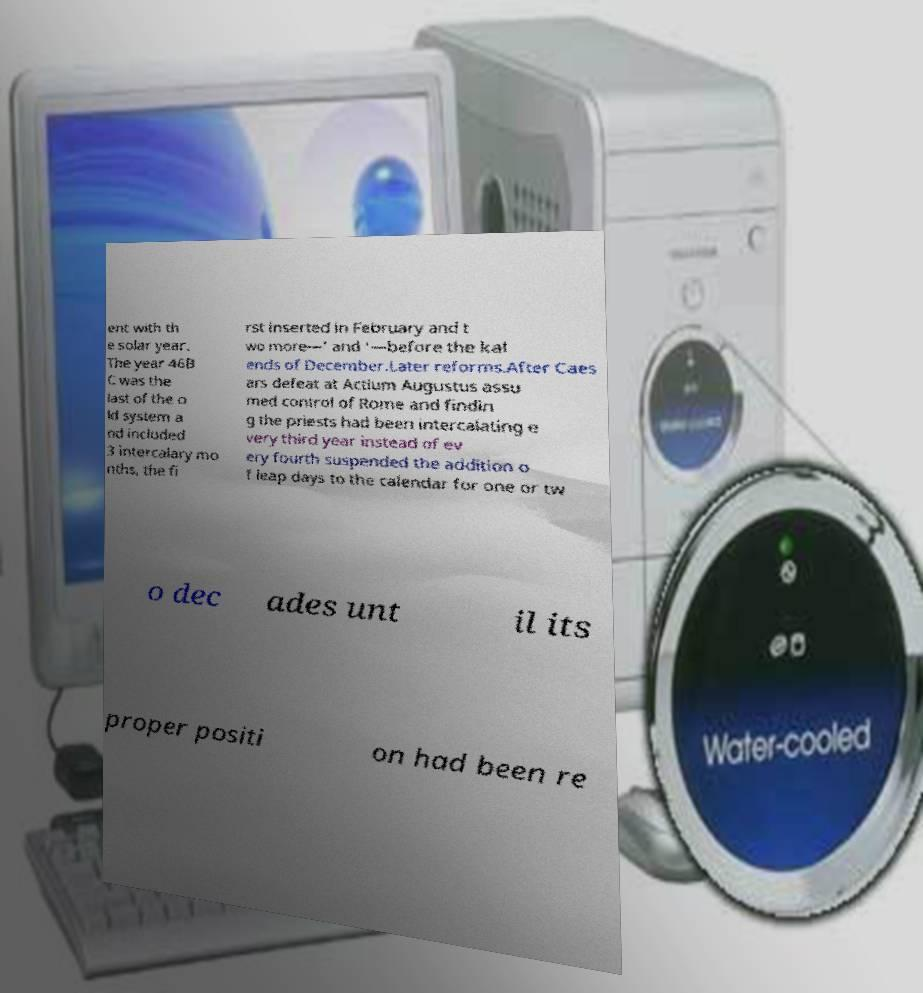Can you read and provide the text displayed in the image?This photo seems to have some interesting text. Can you extract and type it out for me? ent with th e solar year. The year 46B C was the last of the o ld system a nd included 3 intercalary mo nths, the fi rst inserted in February and t wo more—' and '—before the kal ends of December.Later reforms.After Caes ars defeat at Actium Augustus assu med control of Rome and findin g the priests had been intercalating e very third year instead of ev ery fourth suspended the addition o f leap days to the calendar for one or tw o dec ades unt il its proper positi on had been re 